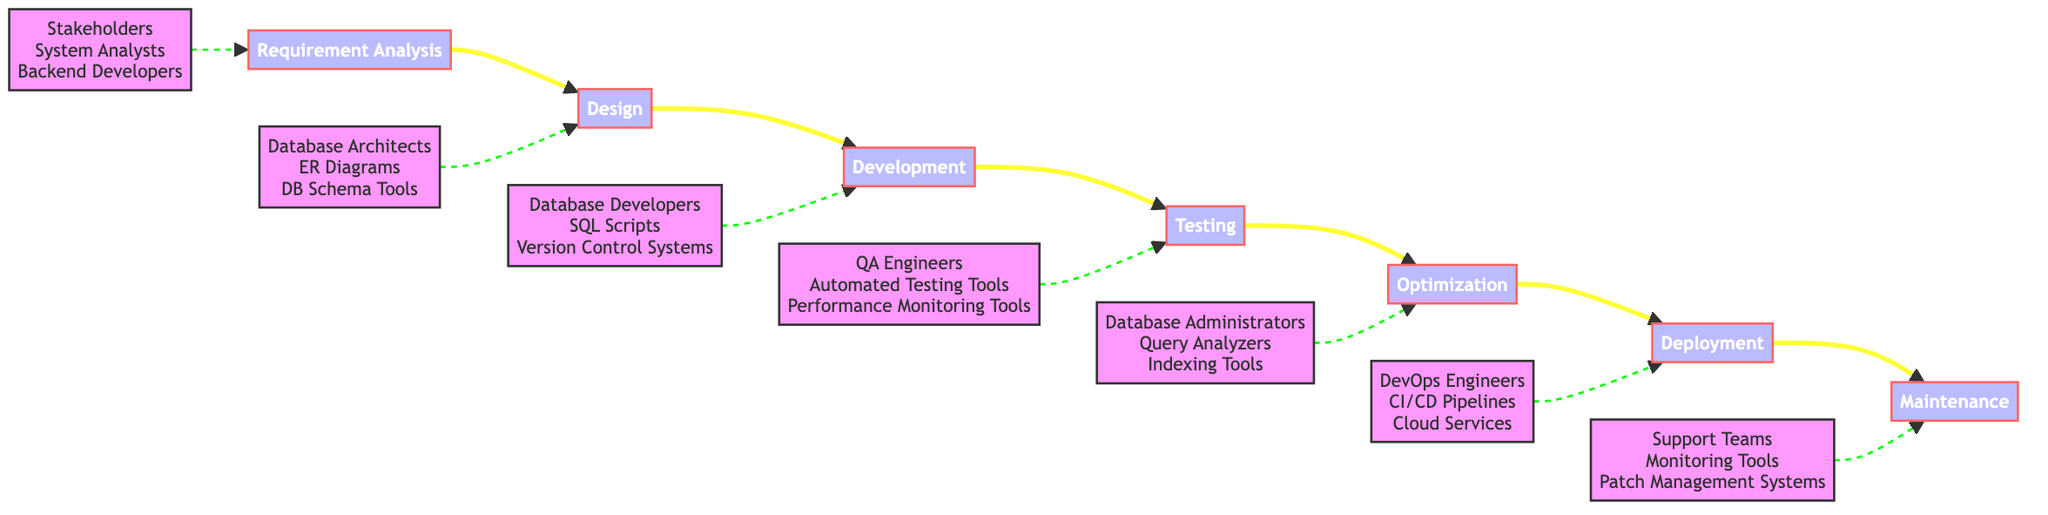What is the first phase in the database development lifecycle? The diagram starts with "Requirement Analysis" as the first phase, which is evident at the leftmost position of the flowchart.
Answer: Requirement Analysis How many phases are in the database development lifecycle? By counting each distinct phase node along the flow, there are a total of seven phases listed in the flowchart.
Answer: Seven Which entities are associated with the "Testing" phase? The diagram includes a dashed connection pointing to the "Testing" phase that lists "QA Engineers, Automated Testing Tools, Performance Monitoring Tools," indicating these are the related entities.
Answer: QA Engineers, Automated Testing Tools, Performance Monitoring Tools What is the transition from "Development" to "Testing"? The flowchart shows a direct arrow from "Development" to "Testing," indicating that the next step in the process involves testing the components developed in the previous phase.
Answer: Direct arrow Which phase follows "Optimization"? According to the flowchart, "Deployment" follows "Optimization," as it is the next phase in the horizontal flow after optimization is completed.
Answer: Deployment What type of tools are used in the "Design" phase? The dashed connection to "Design" identifies "Database Architects, ER Diagrams, DB Schema Tools" as the tools or entities utilized during the design phase, providing clarity on resources associated with that phase.
Answer: Database Architects, ER Diagrams, DB Schema Tools What is the last phase in the development lifecycle? The last node in the flowchart is "Maintenance," indicating it is the final phase of the development lifecycle where ongoing support and updates are conducted.
Answer: Maintenance Which phase has a focus on optimization? "Optimization" is the phase explicitly highlighted in the diagram focusing on optimizing database queries and structures, indicated by the description associated with that node.
Answer: Optimization What type of teams are responsible for the "Maintenance" phase? The dashed line leading to "Maintenance" specifies that "Support Teams, Monitoring Tools, Patch Management Systems" are responsible for activities in the maintenance phase, detailing the entities involved.
Answer: Support Teams, Monitoring Tools, Patch Management Systems 